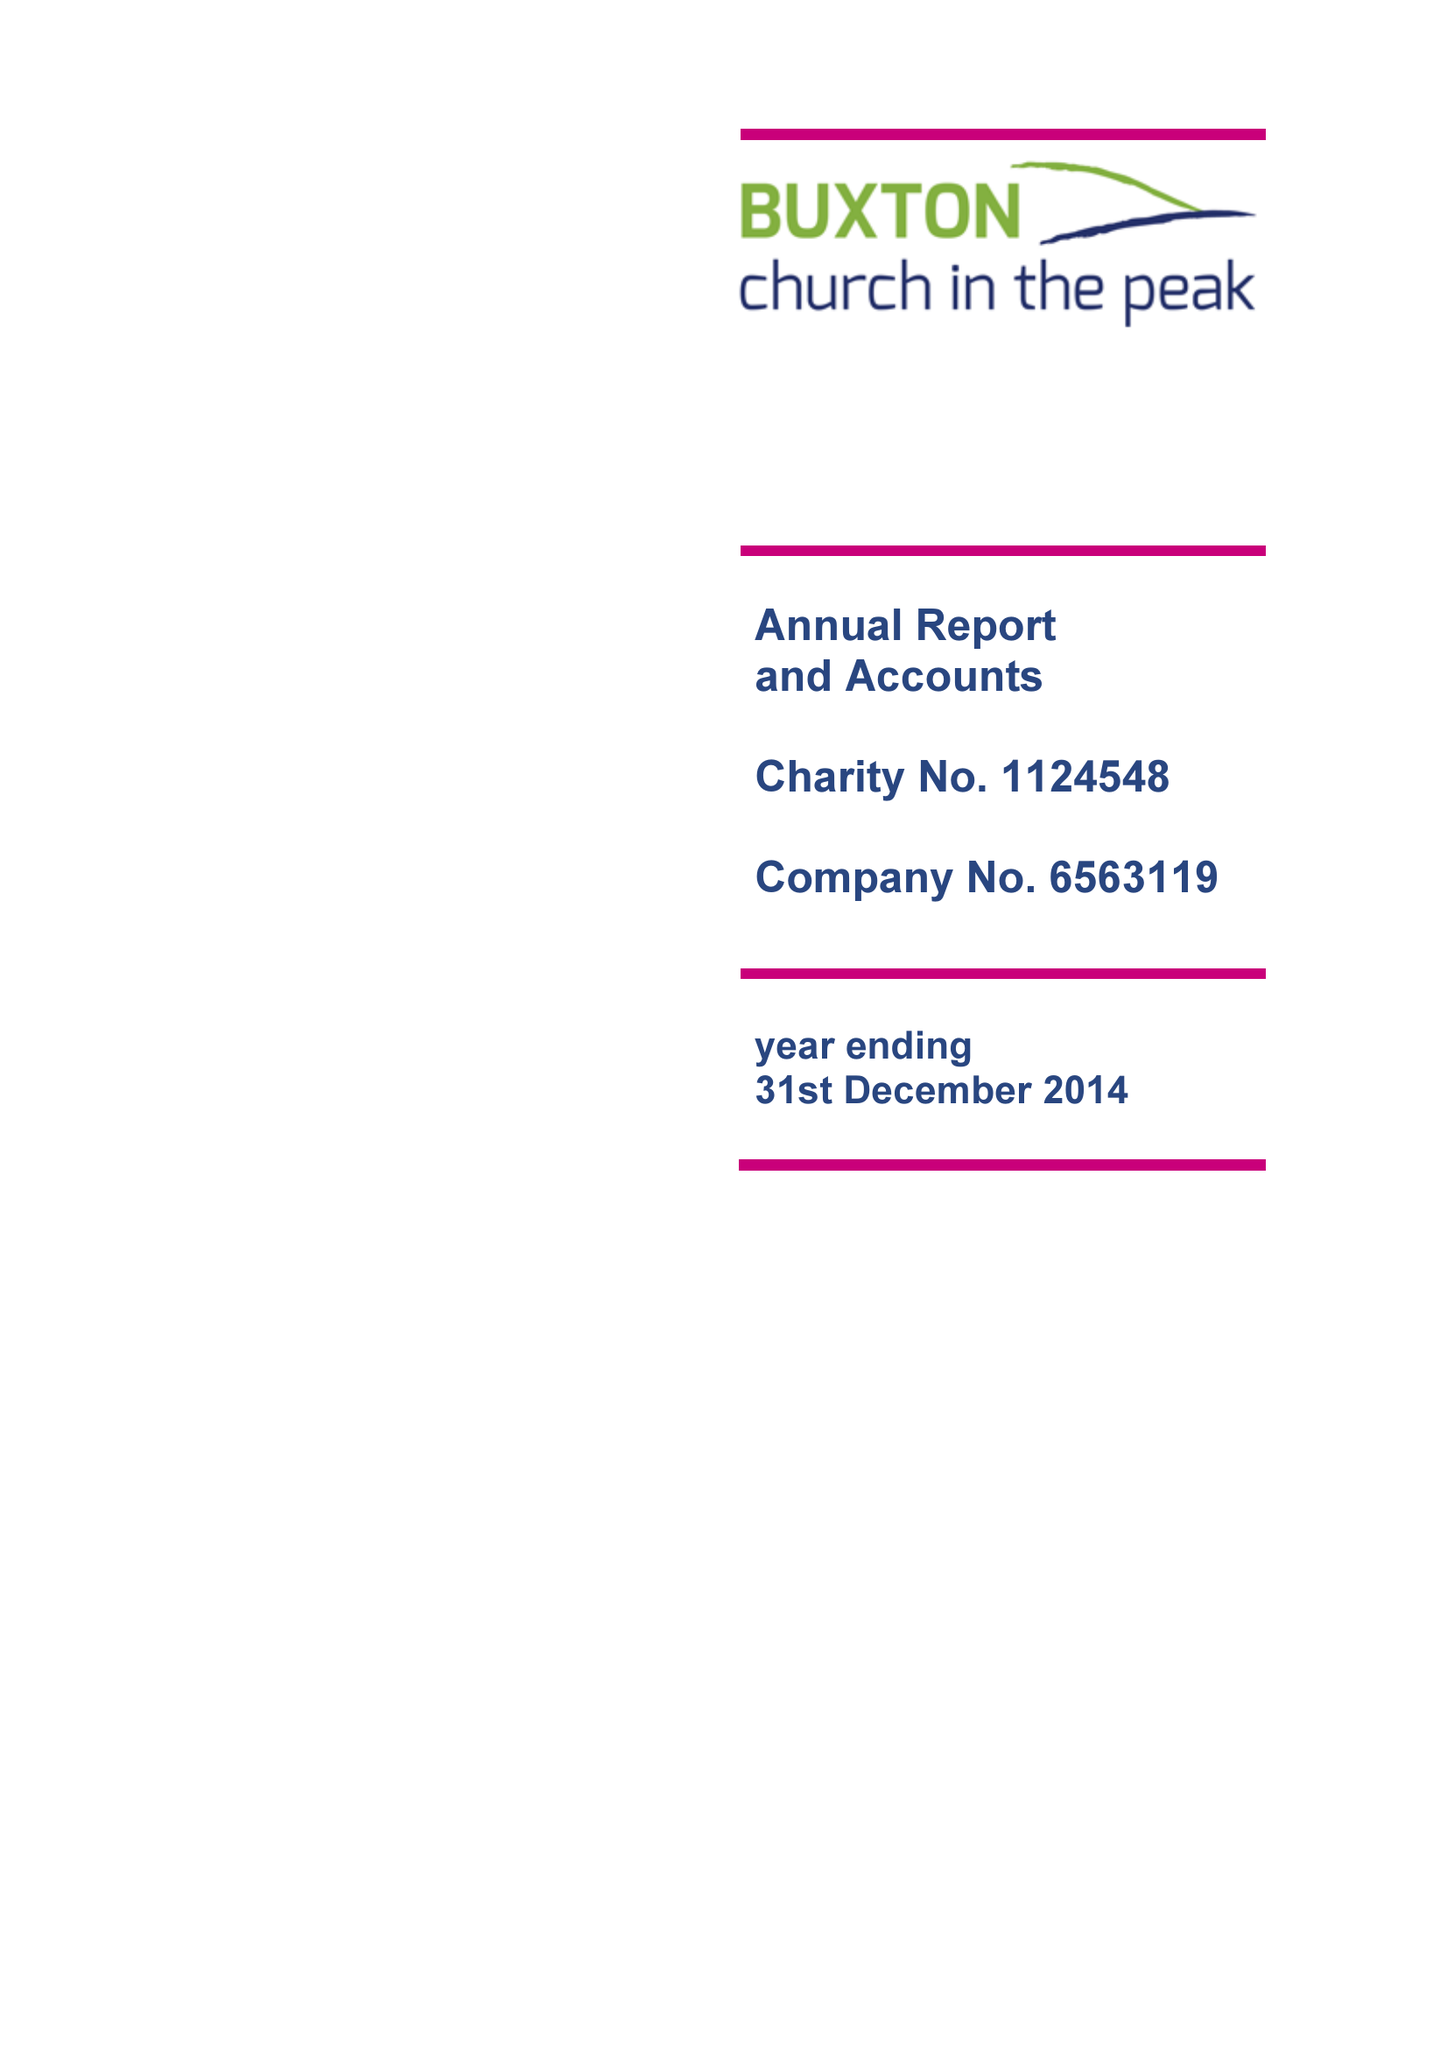What is the value for the spending_annually_in_british_pounds?
Answer the question using a single word or phrase. 105731.00 